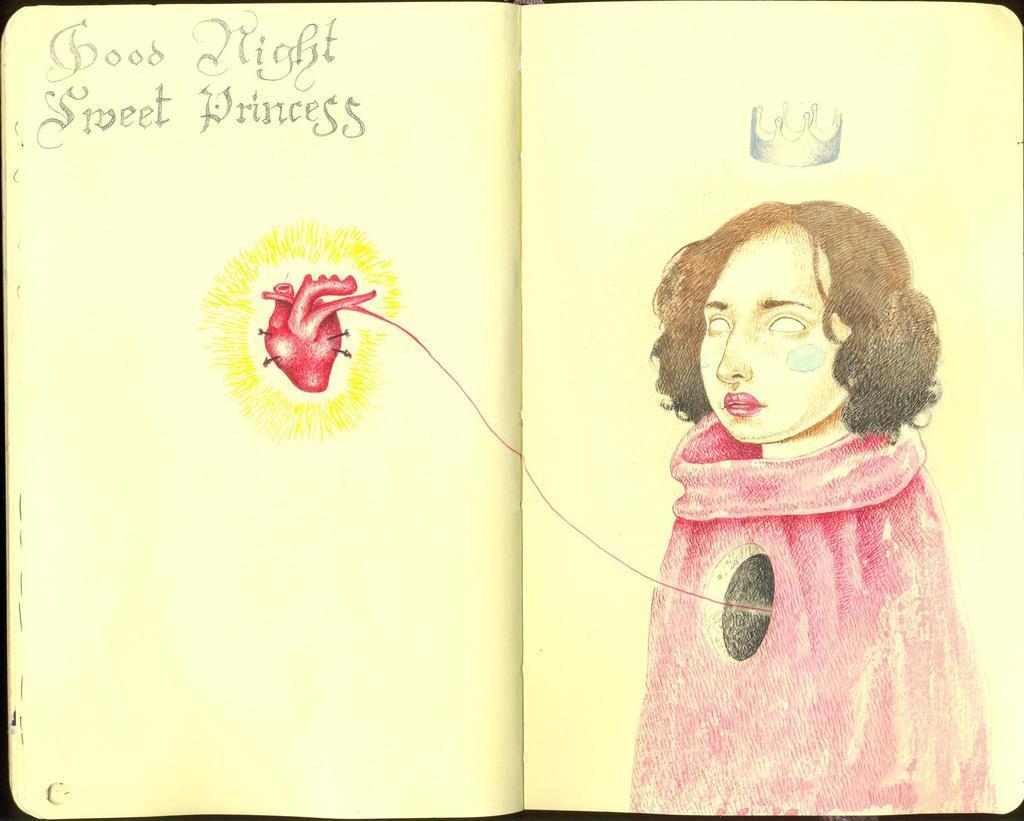Please provide a concise description of this image. In this image we can see one open book with text and images. There is a woman, crown and heart images. 